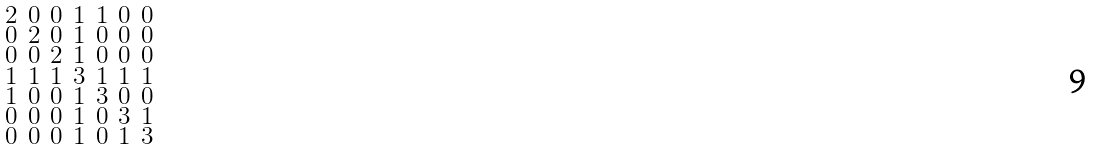Convert formula to latex. <formula><loc_0><loc_0><loc_500><loc_500>\begin{smallmatrix} 2 & 0 & 0 & 1 & 1 & 0 & 0 \\ 0 & 2 & 0 & 1 & 0 & 0 & 0 \\ 0 & 0 & 2 & 1 & 0 & 0 & 0 \\ 1 & 1 & 1 & 3 & 1 & 1 & 1 \\ 1 & 0 & 0 & 1 & 3 & 0 & 0 \\ 0 & 0 & 0 & 1 & 0 & 3 & 1 \\ 0 & 0 & 0 & 1 & 0 & 1 & 3 \end{smallmatrix}</formula> 